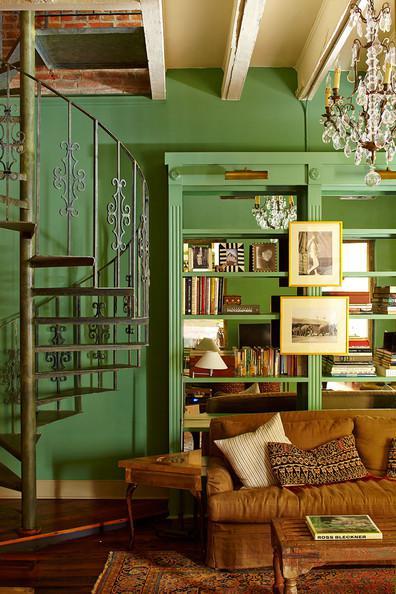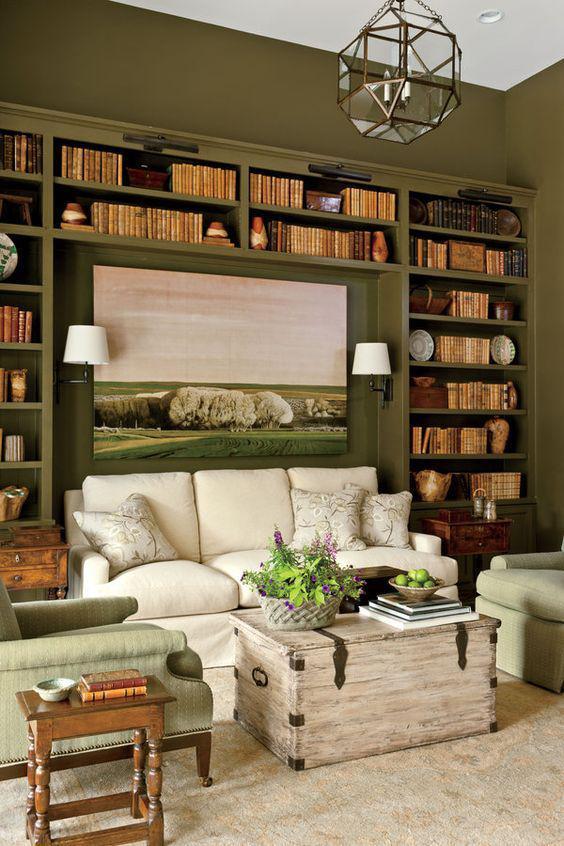The first image is the image on the left, the second image is the image on the right. Given the left and right images, does the statement "The left image shows framed pictures on the front of green bookshelves in front of a green wall, and a brown sofa in front of the bookshelves." hold true? Answer yes or no. Yes. The first image is the image on the left, the second image is the image on the right. Assess this claim about the two images: "In at least one image there is a green wall with at least two framed pictures.". Correct or not? Answer yes or no. Yes. 